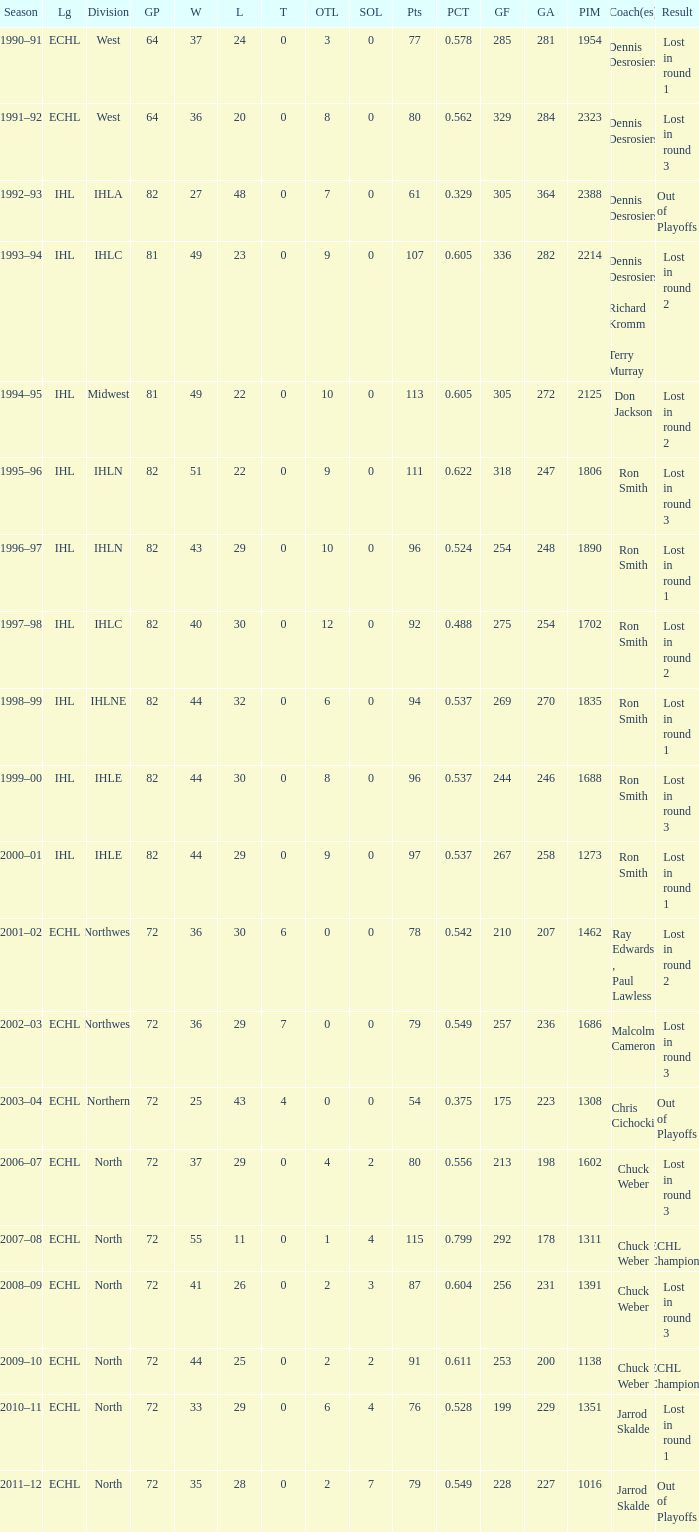What was the season where the team reached a GP of 244? 1999–00. 